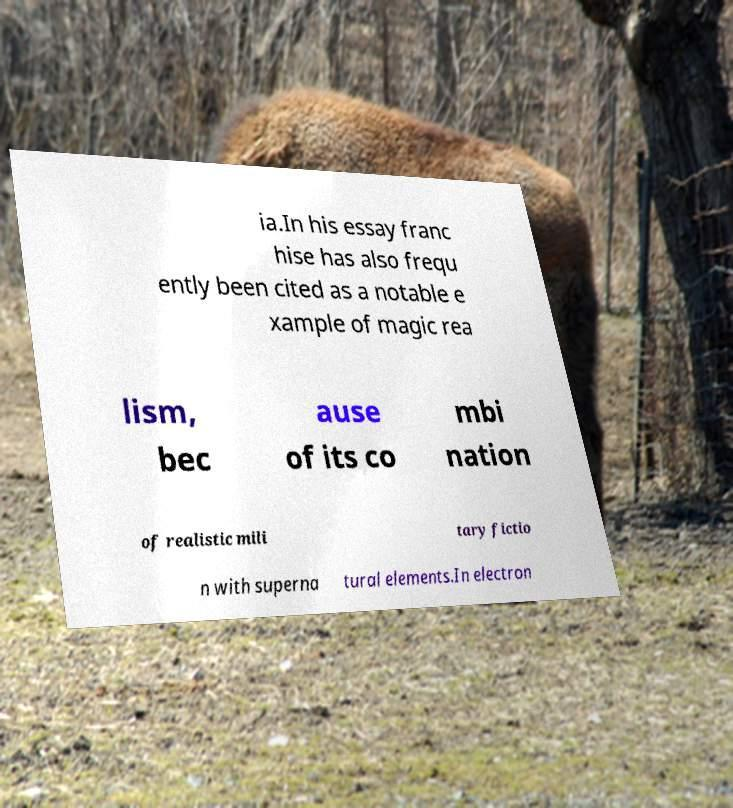There's text embedded in this image that I need extracted. Can you transcribe it verbatim? ia.In his essay franc hise has also frequ ently been cited as a notable e xample of magic rea lism, bec ause of its co mbi nation of realistic mili tary fictio n with superna tural elements.In electron 